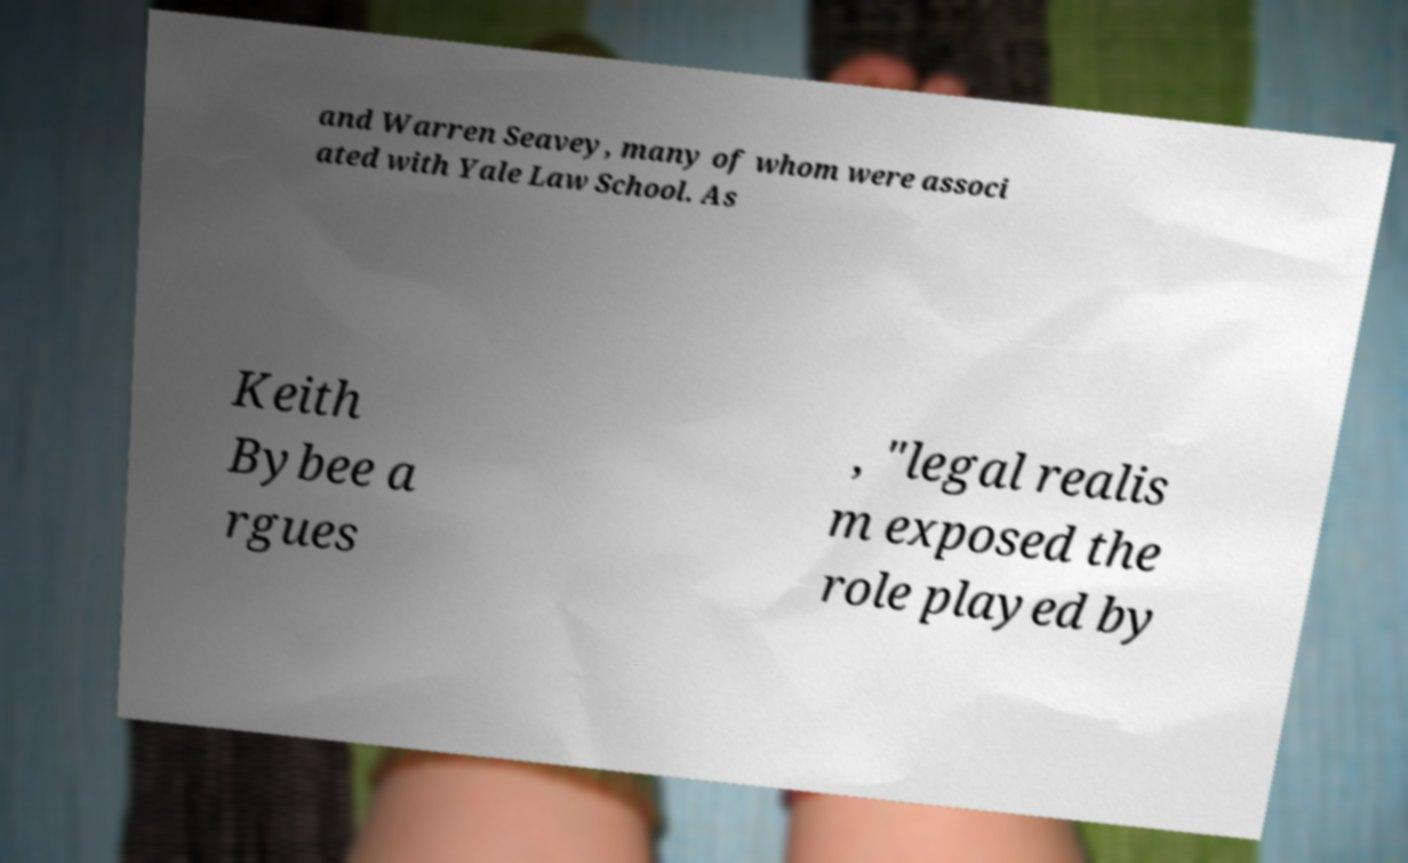Could you assist in decoding the text presented in this image and type it out clearly? and Warren Seavey, many of whom were associ ated with Yale Law School. As Keith Bybee a rgues , "legal realis m exposed the role played by 